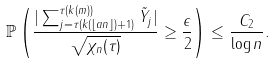Convert formula to latex. <formula><loc_0><loc_0><loc_500><loc_500>\mathbb { P } \left ( \frac { | \sum _ { j = \tau ( k ( \lfloor a n \rfloor ) + 1 ) } ^ { \tau ( k ( m ) ) } \tilde { Y } _ { j } | } { \sqrt { \chi _ { n } ( \tau ) } } \geq \frac { \epsilon } { 2 } \right ) \leq \frac { C _ { 2 } } { \log n } .</formula> 